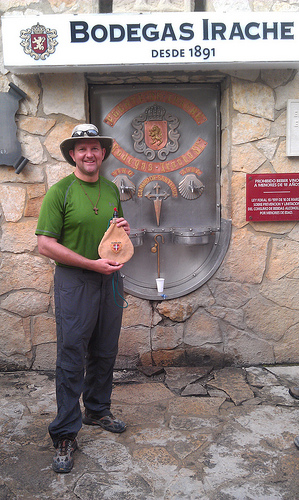<image>
Can you confirm if the man is under the wall? No. The man is not positioned under the wall. The vertical relationship between these objects is different. 